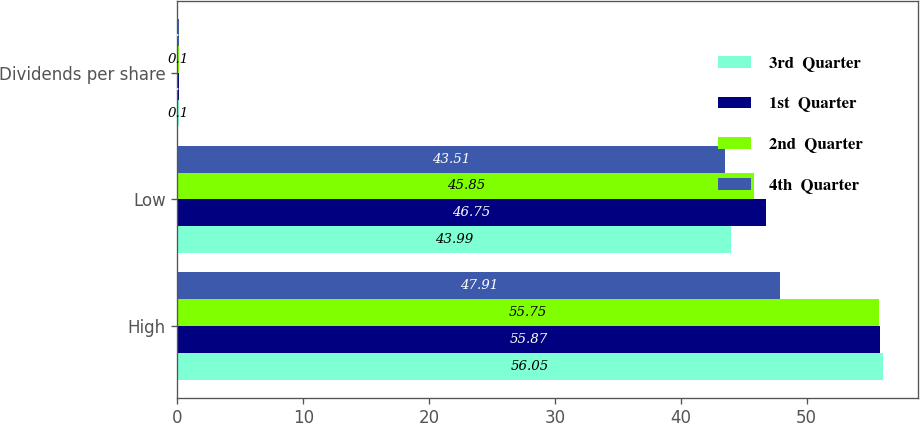Convert chart to OTSL. <chart><loc_0><loc_0><loc_500><loc_500><stacked_bar_chart><ecel><fcel>High<fcel>Low<fcel>Dividends per share<nl><fcel>3rd  Quarter<fcel>56.05<fcel>43.99<fcel>0.1<nl><fcel>1st  Quarter<fcel>55.87<fcel>46.75<fcel>0.1<nl><fcel>2nd  Quarter<fcel>55.75<fcel>45.85<fcel>0.1<nl><fcel>4th  Quarter<fcel>47.91<fcel>43.51<fcel>0.1<nl></chart> 